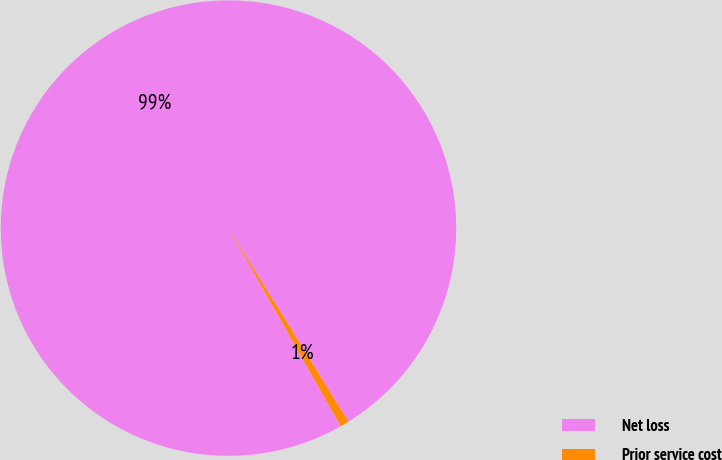Convert chart. <chart><loc_0><loc_0><loc_500><loc_500><pie_chart><fcel>Net loss<fcel>Prior service cost<nl><fcel>99.37%<fcel>0.63%<nl></chart> 